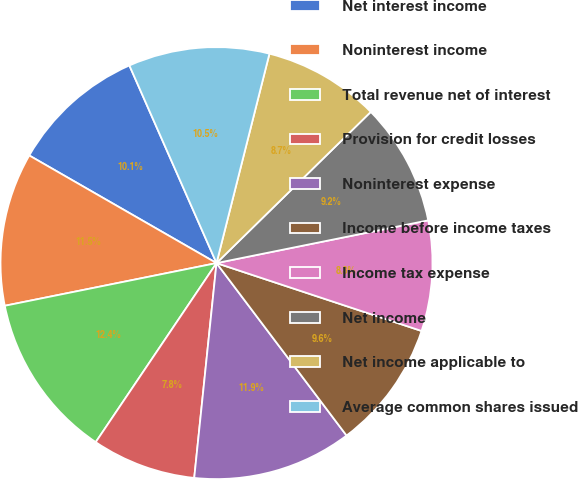Convert chart. <chart><loc_0><loc_0><loc_500><loc_500><pie_chart><fcel>Net interest income<fcel>Noninterest income<fcel>Total revenue net of interest<fcel>Provision for credit losses<fcel>Noninterest expense<fcel>Income before income taxes<fcel>Income tax expense<fcel>Net income<fcel>Net income applicable to<fcel>Average common shares issued<nl><fcel>10.09%<fcel>11.47%<fcel>12.39%<fcel>7.8%<fcel>11.93%<fcel>9.63%<fcel>8.26%<fcel>9.17%<fcel>8.72%<fcel>10.55%<nl></chart> 